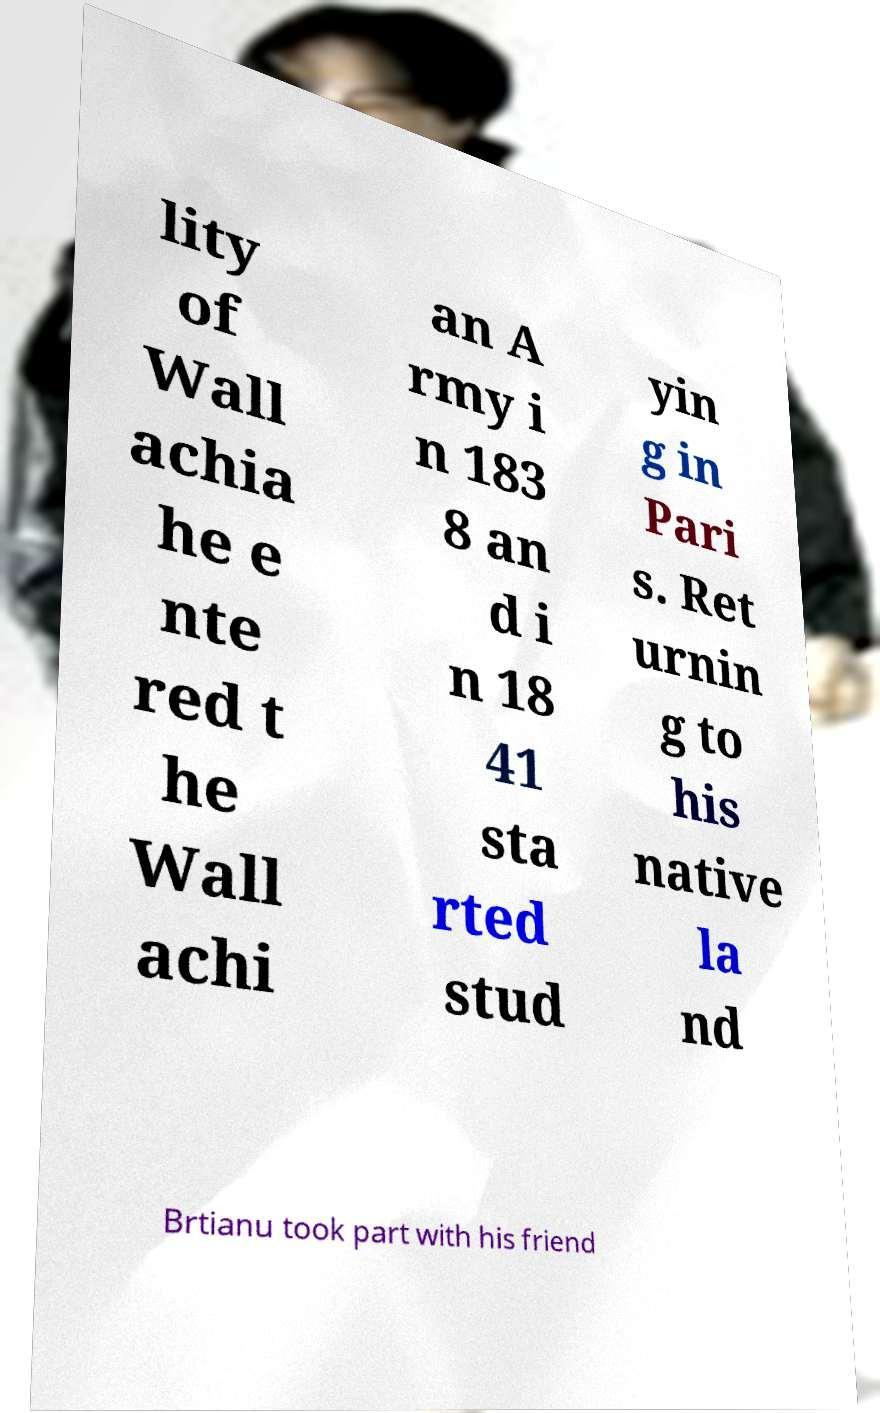For documentation purposes, I need the text within this image transcribed. Could you provide that? lity of Wall achia he e nte red t he Wall achi an A rmy i n 183 8 an d i n 18 41 sta rted stud yin g in Pari s. Ret urnin g to his native la nd Brtianu took part with his friend 